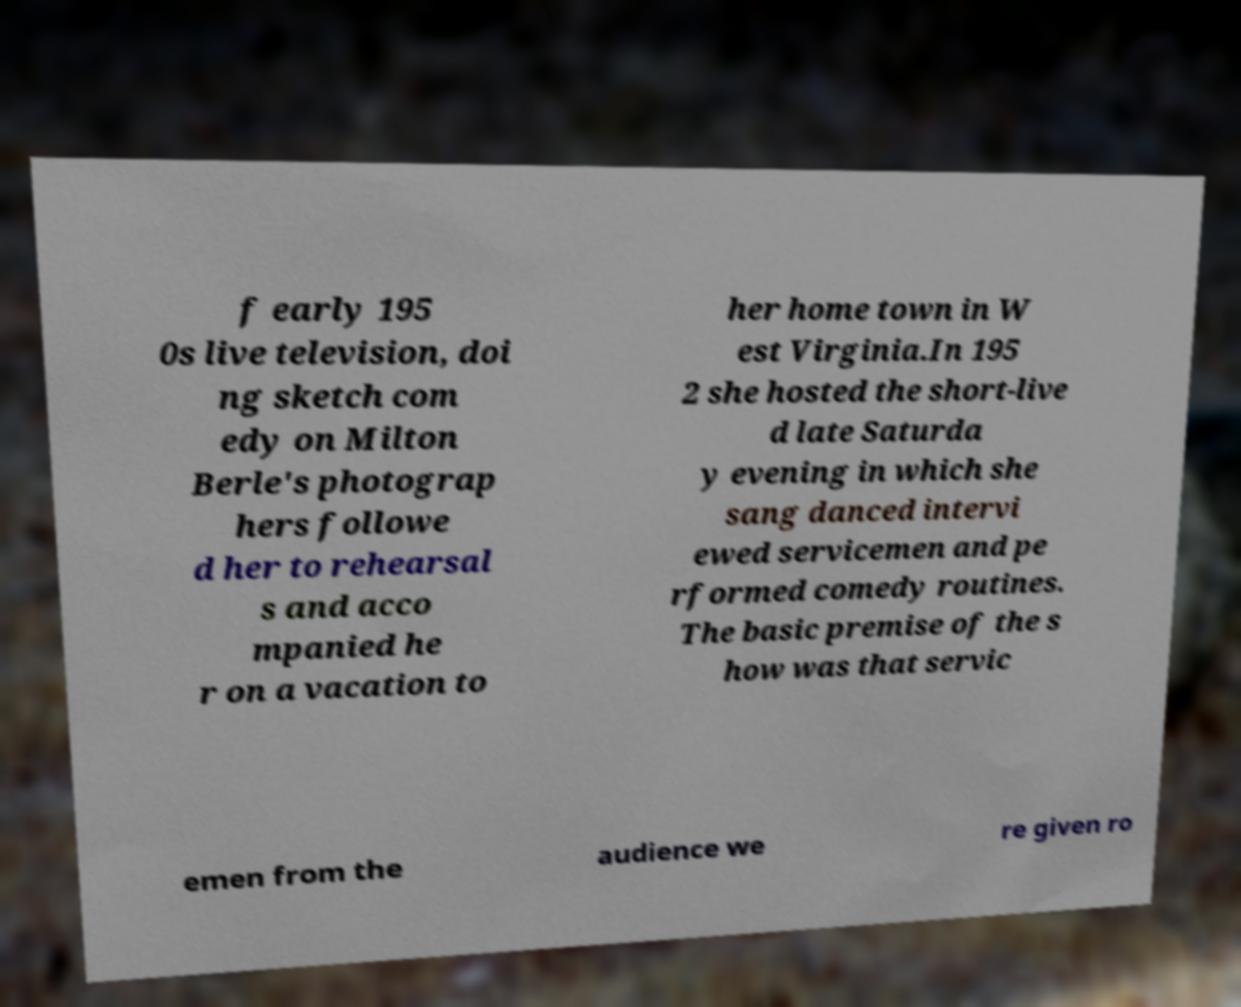Could you extract and type out the text from this image? f early 195 0s live television, doi ng sketch com edy on Milton Berle's photograp hers followe d her to rehearsal s and acco mpanied he r on a vacation to her home town in W est Virginia.In 195 2 she hosted the short-live d late Saturda y evening in which she sang danced intervi ewed servicemen and pe rformed comedy routines. The basic premise of the s how was that servic emen from the audience we re given ro 